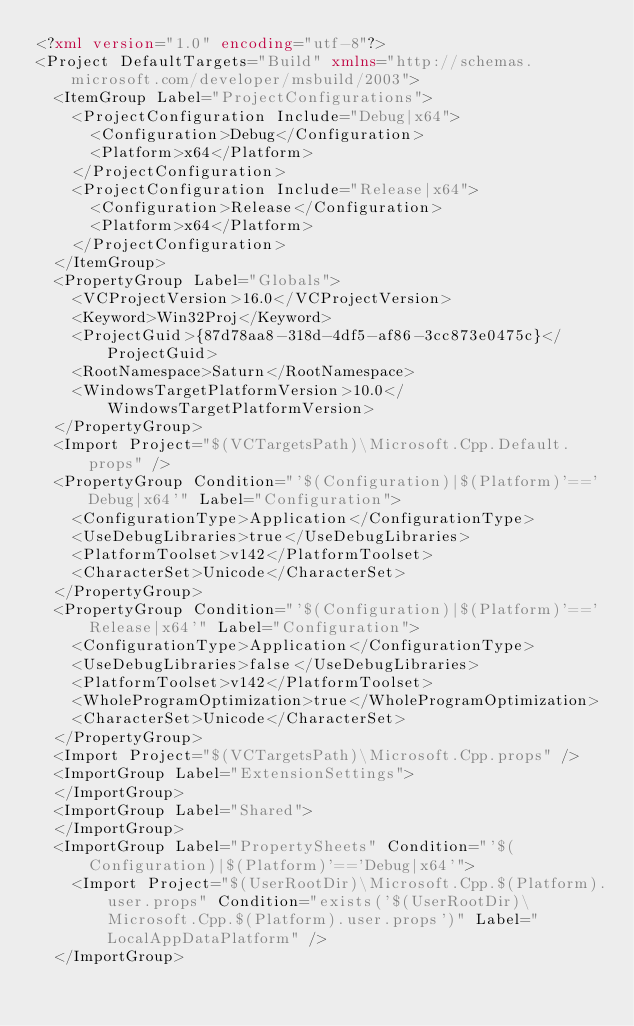Convert code to text. <code><loc_0><loc_0><loc_500><loc_500><_XML_><?xml version="1.0" encoding="utf-8"?>
<Project DefaultTargets="Build" xmlns="http://schemas.microsoft.com/developer/msbuild/2003">
  <ItemGroup Label="ProjectConfigurations">
    <ProjectConfiguration Include="Debug|x64">
      <Configuration>Debug</Configuration>
      <Platform>x64</Platform>
    </ProjectConfiguration>
    <ProjectConfiguration Include="Release|x64">
      <Configuration>Release</Configuration>
      <Platform>x64</Platform>
    </ProjectConfiguration>
  </ItemGroup>
  <PropertyGroup Label="Globals">
    <VCProjectVersion>16.0</VCProjectVersion>
    <Keyword>Win32Proj</Keyword>
    <ProjectGuid>{87d78aa8-318d-4df5-af86-3cc873e0475c}</ProjectGuid>
    <RootNamespace>Saturn</RootNamespace>
    <WindowsTargetPlatformVersion>10.0</WindowsTargetPlatformVersion>
  </PropertyGroup>
  <Import Project="$(VCTargetsPath)\Microsoft.Cpp.Default.props" />
  <PropertyGroup Condition="'$(Configuration)|$(Platform)'=='Debug|x64'" Label="Configuration">
    <ConfigurationType>Application</ConfigurationType>
    <UseDebugLibraries>true</UseDebugLibraries>
    <PlatformToolset>v142</PlatformToolset>
    <CharacterSet>Unicode</CharacterSet>
  </PropertyGroup>
  <PropertyGroup Condition="'$(Configuration)|$(Platform)'=='Release|x64'" Label="Configuration">
    <ConfigurationType>Application</ConfigurationType>
    <UseDebugLibraries>false</UseDebugLibraries>
    <PlatformToolset>v142</PlatformToolset>
    <WholeProgramOptimization>true</WholeProgramOptimization>
    <CharacterSet>Unicode</CharacterSet>
  </PropertyGroup>
  <Import Project="$(VCTargetsPath)\Microsoft.Cpp.props" />
  <ImportGroup Label="ExtensionSettings">
  </ImportGroup>
  <ImportGroup Label="Shared">
  </ImportGroup>
  <ImportGroup Label="PropertySheets" Condition="'$(Configuration)|$(Platform)'=='Debug|x64'">
    <Import Project="$(UserRootDir)\Microsoft.Cpp.$(Platform).user.props" Condition="exists('$(UserRootDir)\Microsoft.Cpp.$(Platform).user.props')" Label="LocalAppDataPlatform" />
  </ImportGroup></code> 